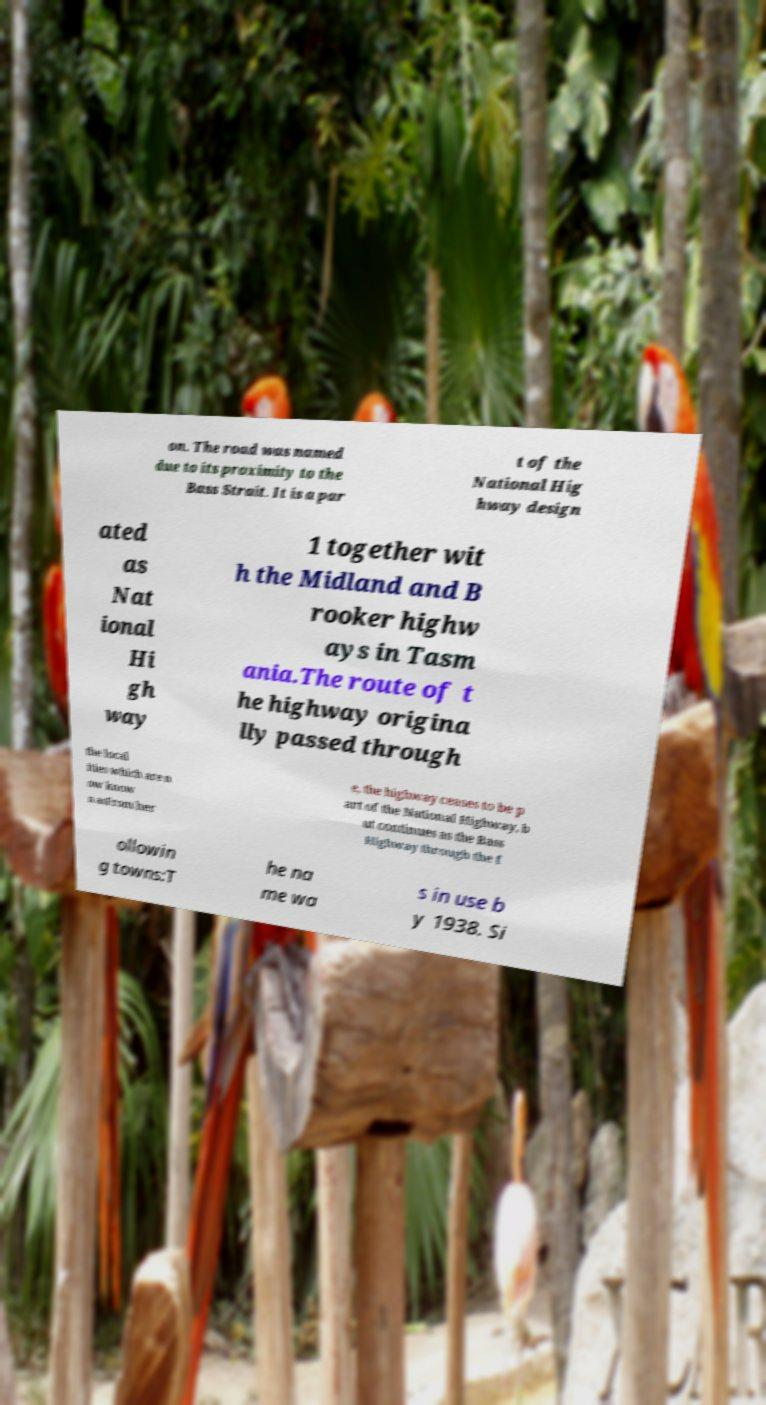Please identify and transcribe the text found in this image. on. The road was named due to its proximity to the Bass Strait. It is a par t of the National Hig hway design ated as Nat ional Hi gh way 1 together wit h the Midland and B rooker highw ays in Tasm ania.The route of t he highway origina lly passed through the local ities which are n ow know n asFrom her e, the highway ceases to be p art of the National Highway, b ut continues as the Bass Highway through the f ollowin g towns:T he na me wa s in use b y 1938. Si 